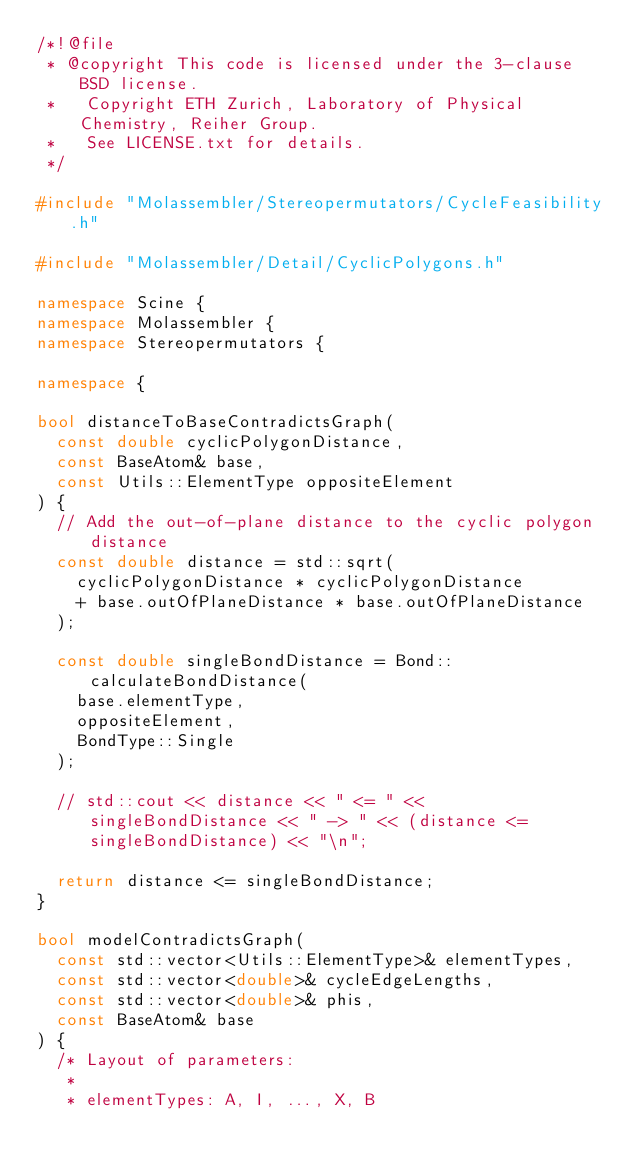Convert code to text. <code><loc_0><loc_0><loc_500><loc_500><_C++_>/*!@file
 * @copyright This code is licensed under the 3-clause BSD license.
 *   Copyright ETH Zurich, Laboratory of Physical Chemistry, Reiher Group.
 *   See LICENSE.txt for details.
 */

#include "Molassembler/Stereopermutators/CycleFeasibility.h"

#include "Molassembler/Detail/CyclicPolygons.h"

namespace Scine {
namespace Molassembler {
namespace Stereopermutators {

namespace {

bool distanceToBaseContradictsGraph(
  const double cyclicPolygonDistance,
  const BaseAtom& base,
  const Utils::ElementType oppositeElement
) {
  // Add the out-of-plane distance to the cyclic polygon distance
  const double distance = std::sqrt(
    cyclicPolygonDistance * cyclicPolygonDistance
    + base.outOfPlaneDistance * base.outOfPlaneDistance
  );

  const double singleBondDistance = Bond::calculateBondDistance(
    base.elementType,
    oppositeElement,
    BondType::Single
  );

  // std::cout << distance << " <= " << singleBondDistance << " -> " << (distance <= singleBondDistance) << "\n";

  return distance <= singleBondDistance;
}

bool modelContradictsGraph(
  const std::vector<Utils::ElementType>& elementTypes,
  const std::vector<double>& cycleEdgeLengths,
  const std::vector<double>& phis,
  const BaseAtom& base
) {
  /* Layout of parameters:
   *
   * elementTypes: A, I, ..., X, B</code> 